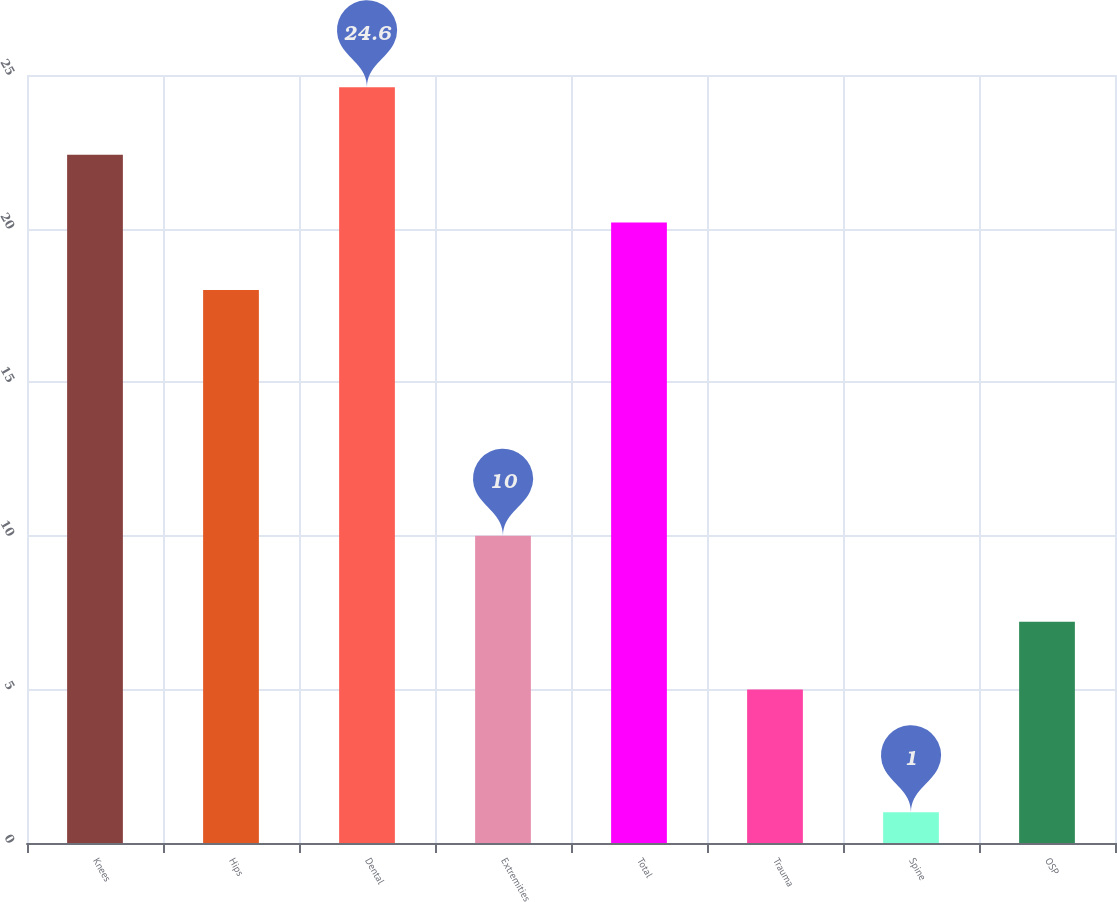Convert chart. <chart><loc_0><loc_0><loc_500><loc_500><bar_chart><fcel>Knees<fcel>Hips<fcel>Dental<fcel>Extremities<fcel>Total<fcel>Trauma<fcel>Spine<fcel>OSP<nl><fcel>22.4<fcel>18<fcel>24.6<fcel>10<fcel>20.2<fcel>5<fcel>1<fcel>7.2<nl></chart> 